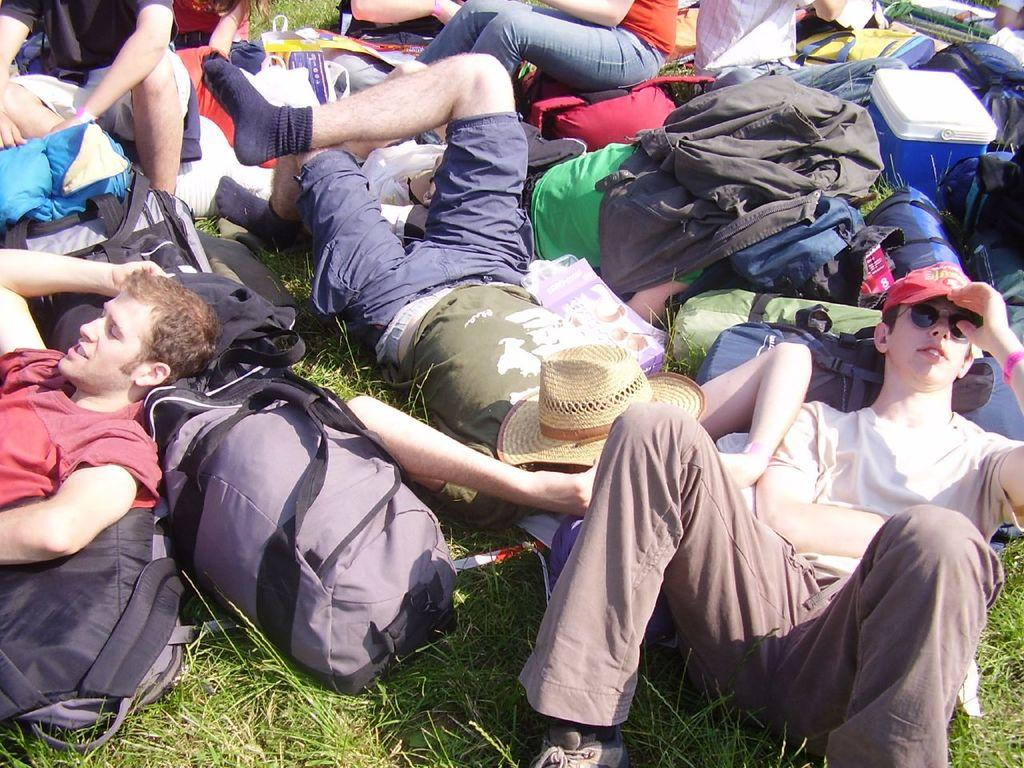How many people are lying down in the image? There are three persons lying down in the image. How many people are sitting in the image? There are two persons sitting in the image. What type of bags can be seen in the image? There are luggage bags in the image. What is the container in the image that might be used for keeping food or drinks cool? There is an insulated basket in the image. What type of terrain is visible in the image? The grass is visible in the image. How many grapes are being eaten by the crow in the image? There is no crow or grapes present in the image. What type of trip are the people in the image on? The image does not provide any information about the purpose or destination of the people, so it cannot be determined if they are on a trip. 